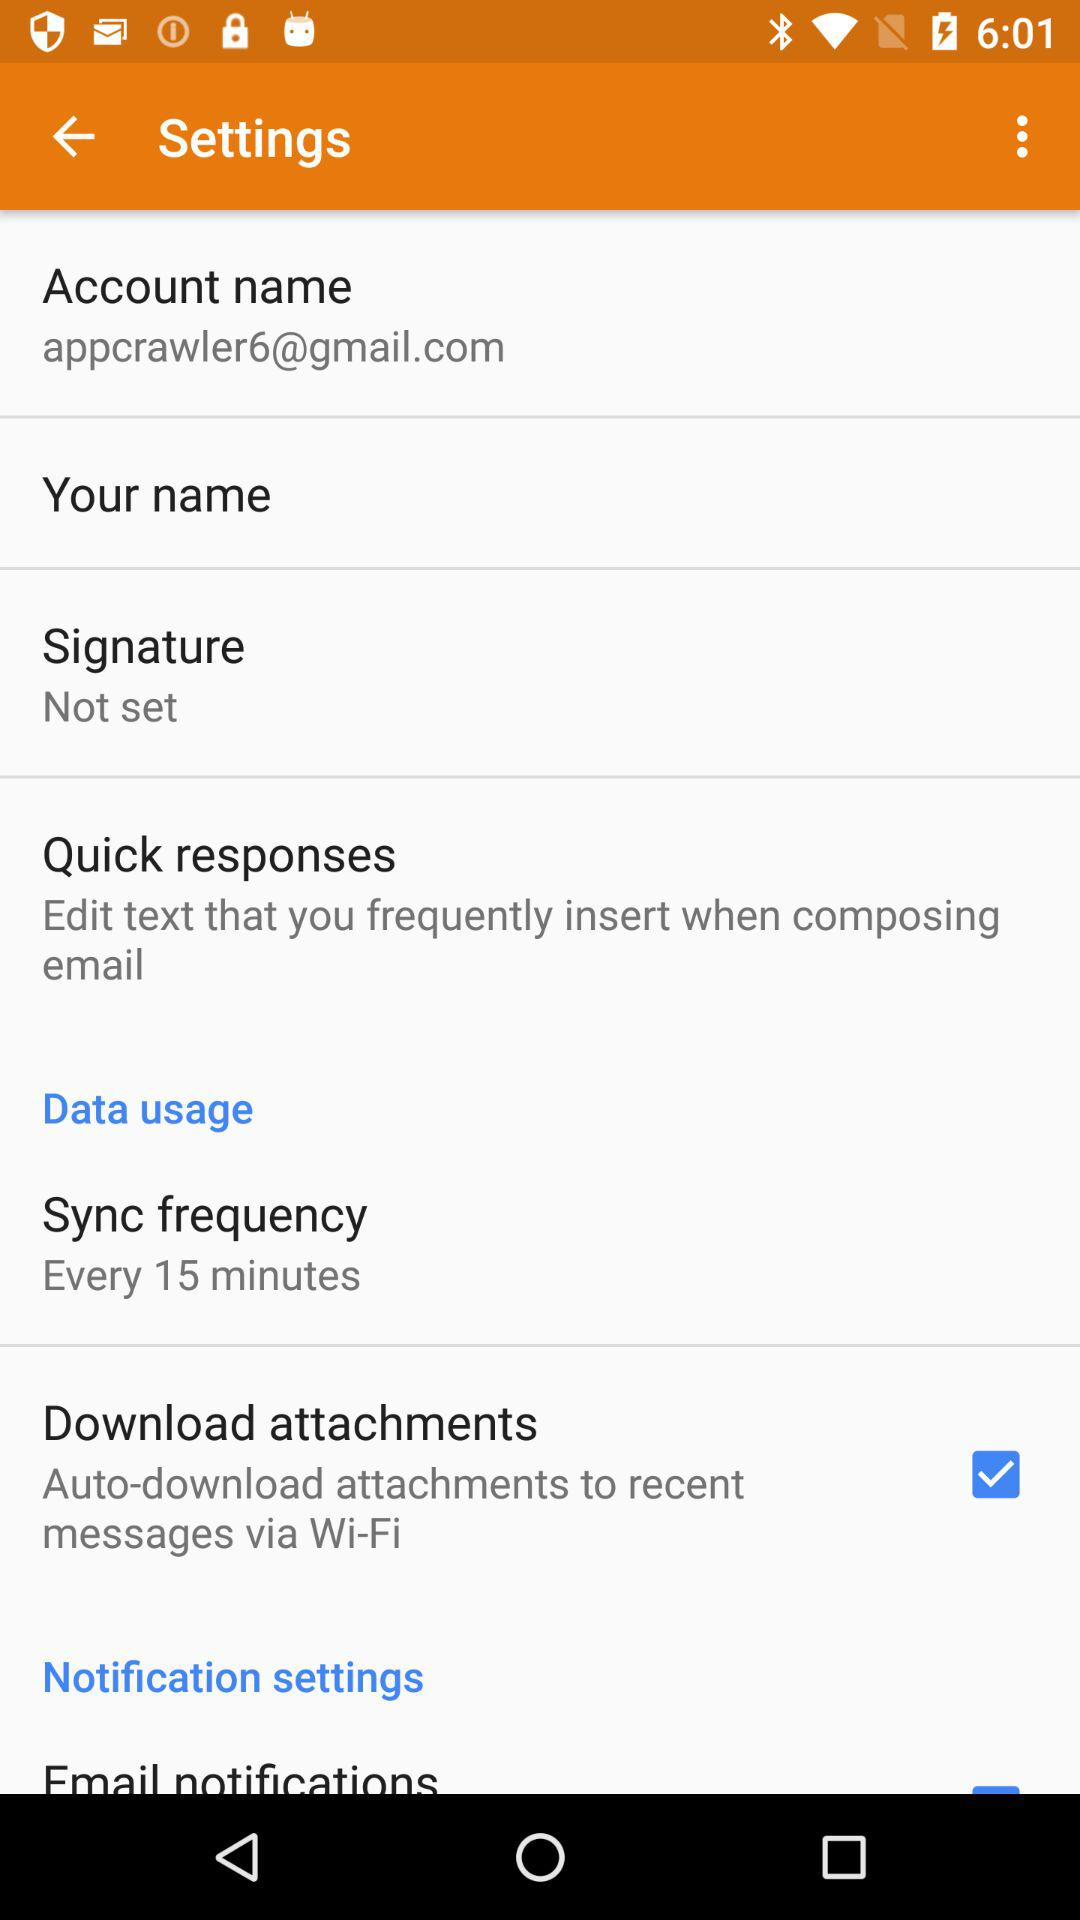What is the status of download attachments? The status is "on". 